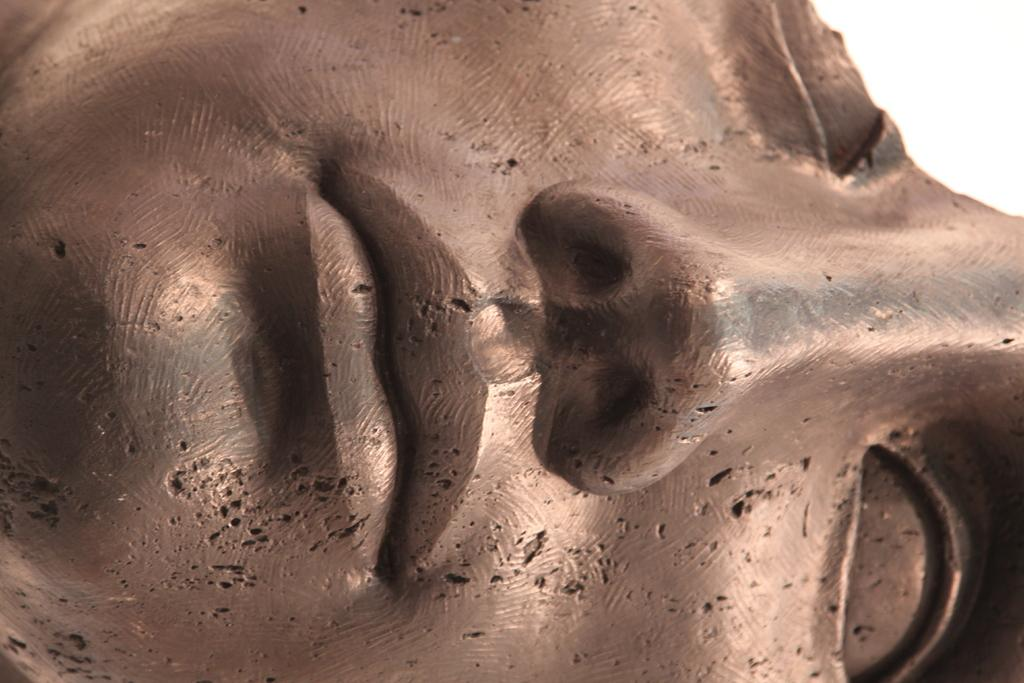What is the main subject of the image? The main subject of the image is a statue. Can you describe the statue in more detail? The statue is of a person's head. How many women are lifting the statue in the image? There are no women lifting the statue in the image, as the statue is the main subject and there are no people present. 